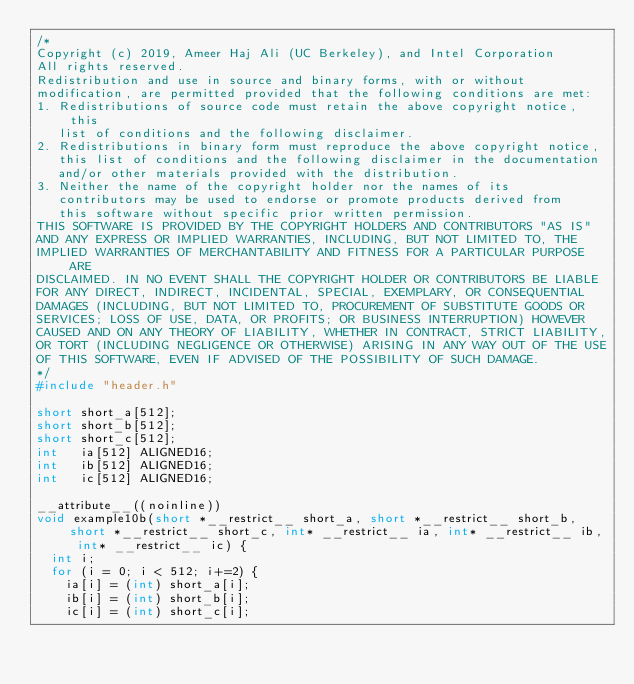<code> <loc_0><loc_0><loc_500><loc_500><_C_>/*
Copyright (c) 2019, Ameer Haj Ali (UC Berkeley), and Intel Corporation
All rights reserved.
Redistribution and use in source and binary forms, with or without
modification, are permitted provided that the following conditions are met:
1. Redistributions of source code must retain the above copyright notice, this
   list of conditions and the following disclaimer.
2. Redistributions in binary form must reproduce the above copyright notice,
   this list of conditions and the following disclaimer in the documentation
   and/or other materials provided with the distribution.
3. Neither the name of the copyright holder nor the names of its
   contributors may be used to endorse or promote products derived from
   this software without specific prior written permission.
THIS SOFTWARE IS PROVIDED BY THE COPYRIGHT HOLDERS AND CONTRIBUTORS "AS IS"
AND ANY EXPRESS OR IMPLIED WARRANTIES, INCLUDING, BUT NOT LIMITED TO, THE
IMPLIED WARRANTIES OF MERCHANTABILITY AND FITNESS FOR A PARTICULAR PURPOSE ARE
DISCLAIMED. IN NO EVENT SHALL THE COPYRIGHT HOLDER OR CONTRIBUTORS BE LIABLE
FOR ANY DIRECT, INDIRECT, INCIDENTAL, SPECIAL, EXEMPLARY, OR CONSEQUENTIAL
DAMAGES (INCLUDING, BUT NOT LIMITED TO, PROCUREMENT OF SUBSTITUTE GOODS OR
SERVICES; LOSS OF USE, DATA, OR PROFITS; OR BUSINESS INTERRUPTION) HOWEVER
CAUSED AND ON ANY THEORY OF LIABILITY, WHETHER IN CONTRACT, STRICT LIABILITY,
OR TORT (INCLUDING NEGLIGENCE OR OTHERWISE) ARISING IN ANY WAY OUT OF THE USE
OF THIS SOFTWARE, EVEN IF ADVISED OF THE POSSIBILITY OF SUCH DAMAGE.
*/
#include "header.h"

short short_a[512];
short short_b[512];
short short_c[512];
int   ia[512] ALIGNED16;
int   ib[512] ALIGNED16;
int   ic[512] ALIGNED16;

__attribute__((noinline))
void example10b(short *__restrict__ short_a, short *__restrict__ short_b, short *__restrict__ short_c, int* __restrict__ ia, int* __restrict__ ib, int* __restrict__ ic) {
  int i;
  for (i = 0; i < 512; i+=2) {
    ia[i] = (int) short_a[i];
    ib[i] = (int) short_b[i];
    ic[i] = (int) short_c[i];</code> 